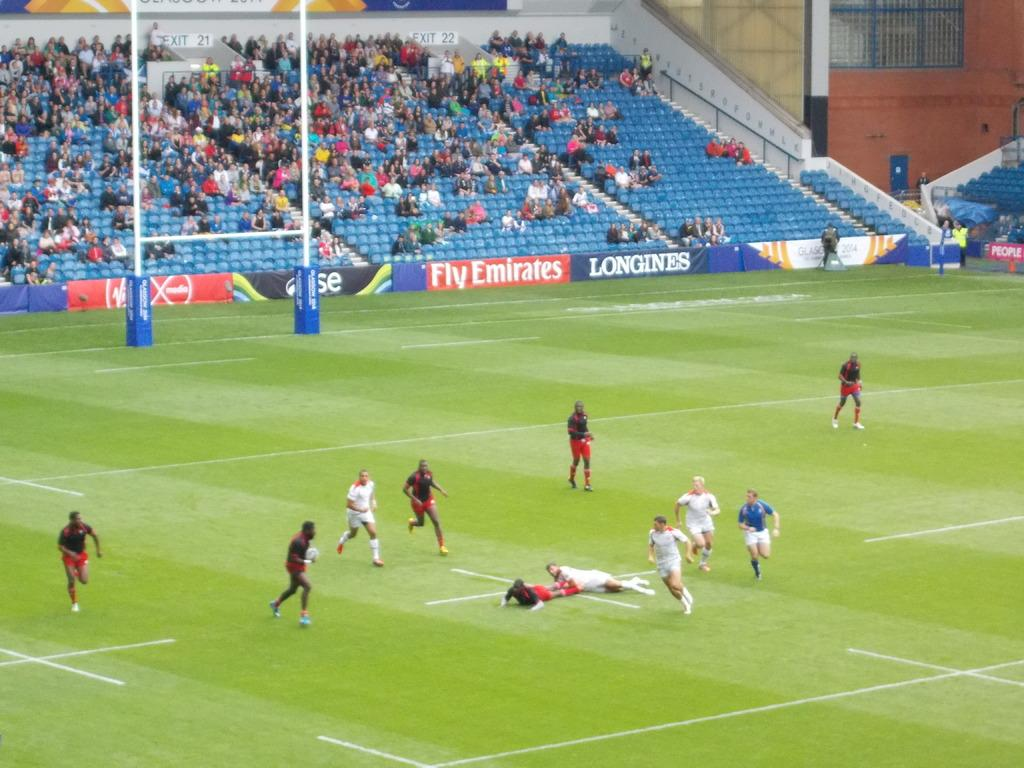<image>
Describe the image concisely. Two teams out on a field with a Fly Emirates advertisement sign shown behind them. 